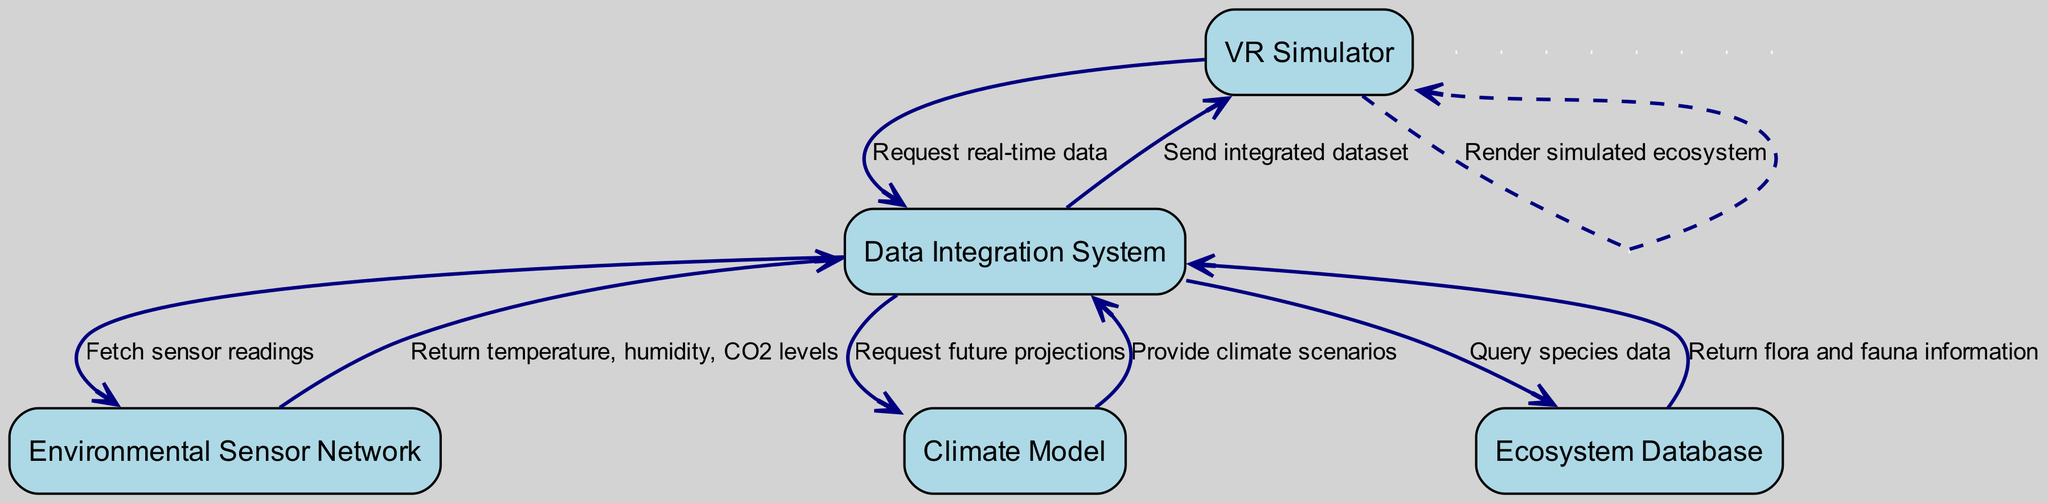What is the first message sent in the sequence? The first message is initiated by the VR Simulator requesting real-time data from the Data Integration System. This is evident as it is the first connection in the diagram.
Answer: Request real-time data How many actors are involved in this sequence diagram? By counting the nodes labeled in the diagram, we find that there are five distinct actors: VR Simulator, Data Integration System, Environmental Sensor Network, Climate Model, and Ecosystem Database.
Answer: 5 Which actor receives the temperature readings? The temperature readings are sent from the Environmental Sensor Network to the Data Integration System. This can be confirmed by tracing the message flow in the diagram.
Answer: Data Integration System What message does the Data Integration System send to the Climate Model? The Data Integration System communicates with the Climate Model by requesting future projections. This is a direct line of communication as shown in the diagram.
Answer: Request future projections What information does the Ecosystem Database return to the Data Integration System? The Ecosystem Database provides the Data Integration System with flora and fauna information, as indicated in the sequence of messages.
Answer: Return flora and fauna information How many unique messages are exchanged in this diagram? By reviewing the sequence of events, we see that there are a total of eight distinct messages exchanged between the actors, each marked by a unique communication line in the diagram.
Answer: 8 Which actor sends the integrated dataset back to the VR Simulator? The Data Integration System is responsible for sending the integrated dataset to the VR Simulator, according to the flow of information depicted in the diagram.
Answer: Data Integration System What is the final action taken by the VR Simulator? The final action depicted in the sequence is that the VR Simulator renders the simulated ecosystem, showcasing the final output of the entire process sequence.
Answer: Render simulated ecosystem 